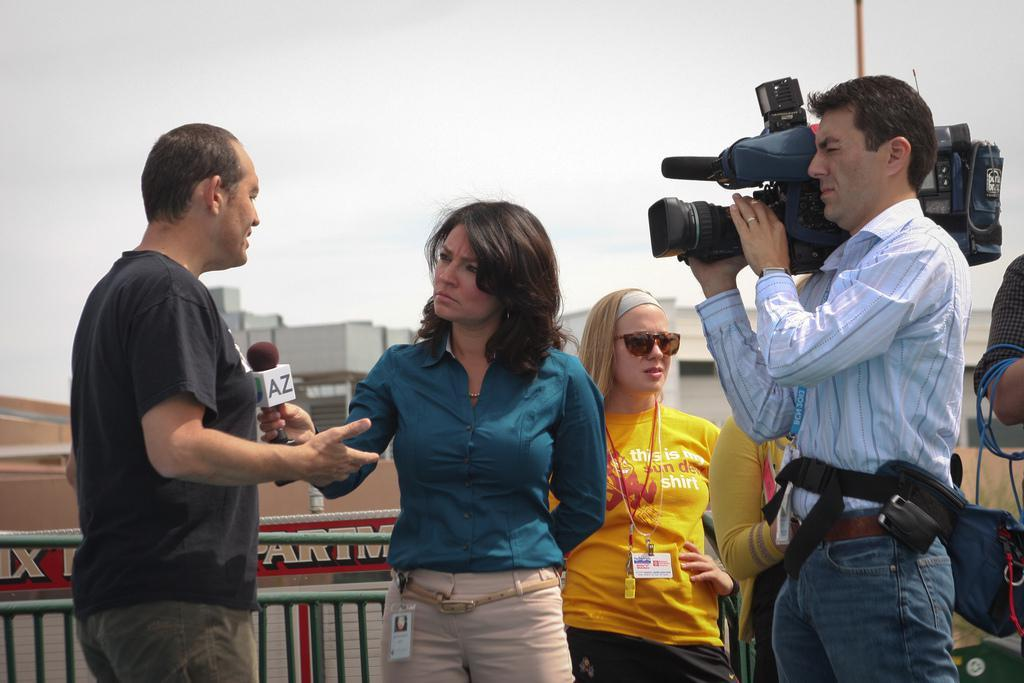How many people are in the image? There is a group of people in the image. What is the woman holding in the image? The woman is holding a microphone. What is the man holding in the image? The man is holding a camera. What can be seen in the background of the image? The sky is visible in the background of the image. Can you see any trails left by the egg in the image? There is no egg or trail present in the image. What type of quill is being used by the woman to write her speech? The woman is holding a microphone, not a quill, and there is no indication that she is writing a speech in the image. 